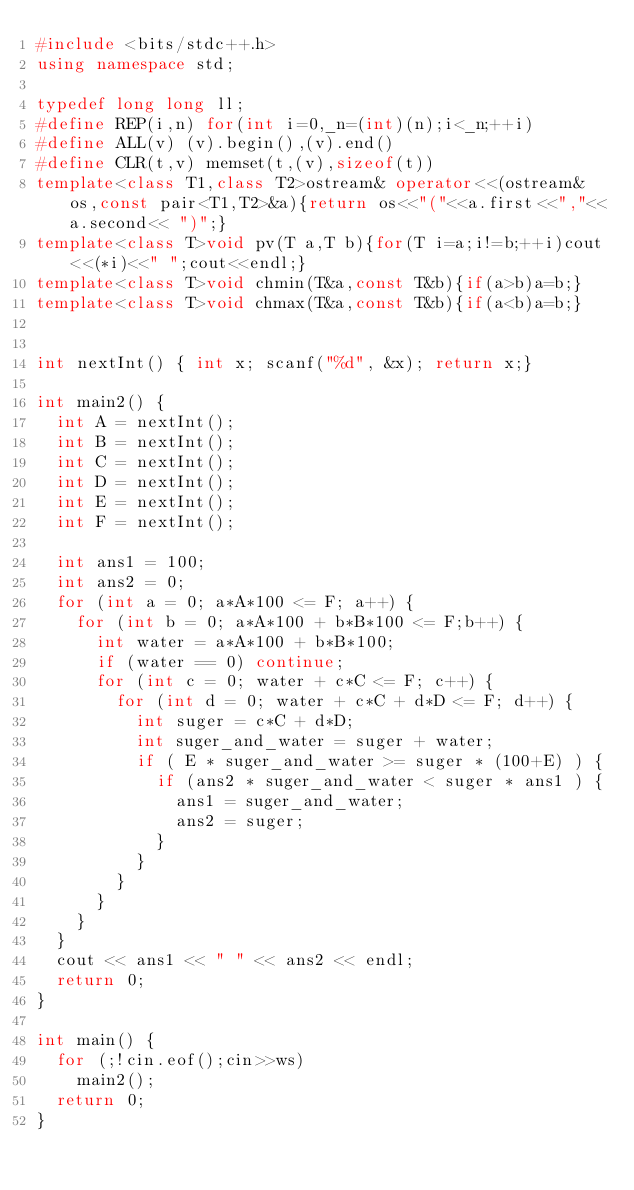Convert code to text. <code><loc_0><loc_0><loc_500><loc_500><_C++_>#include <bits/stdc++.h>
using namespace std;

typedef long long ll;
#define REP(i,n) for(int i=0,_n=(int)(n);i<_n;++i)
#define ALL(v) (v).begin(),(v).end()
#define CLR(t,v) memset(t,(v),sizeof(t))
template<class T1,class T2>ostream& operator<<(ostream& os,const pair<T1,T2>&a){return os<<"("<<a.first<<","<<a.second<< ")";}
template<class T>void pv(T a,T b){for(T i=a;i!=b;++i)cout<<(*i)<<" ";cout<<endl;}
template<class T>void chmin(T&a,const T&b){if(a>b)a=b;}
template<class T>void chmax(T&a,const T&b){if(a<b)a=b;}


int nextInt() { int x; scanf("%d", &x); return x;}

int main2() {
  int A = nextInt();
  int B = nextInt();
  int C = nextInt();
  int D = nextInt();
  int E = nextInt();
  int F = nextInt();

  int ans1 = 100;
  int ans2 = 0;
  for (int a = 0; a*A*100 <= F; a++) {
    for (int b = 0; a*A*100 + b*B*100 <= F;b++) {
      int water = a*A*100 + b*B*100;
      if (water == 0) continue;
      for (int c = 0; water + c*C <= F; c++) {
        for (int d = 0; water + c*C + d*D <= F; d++) {
          int suger = c*C + d*D;
          int suger_and_water = suger + water;
          if ( E * suger_and_water >= suger * (100+E) ) {
            if (ans2 * suger_and_water < suger * ans1 ) {
              ans1 = suger_and_water;
              ans2 = suger;
            }
          }
        }
      }
    }
  }
  cout << ans1 << " " << ans2 << endl;
  return 0;
}

int main() {
  for (;!cin.eof();cin>>ws)
    main2();
  return 0;
}
</code> 